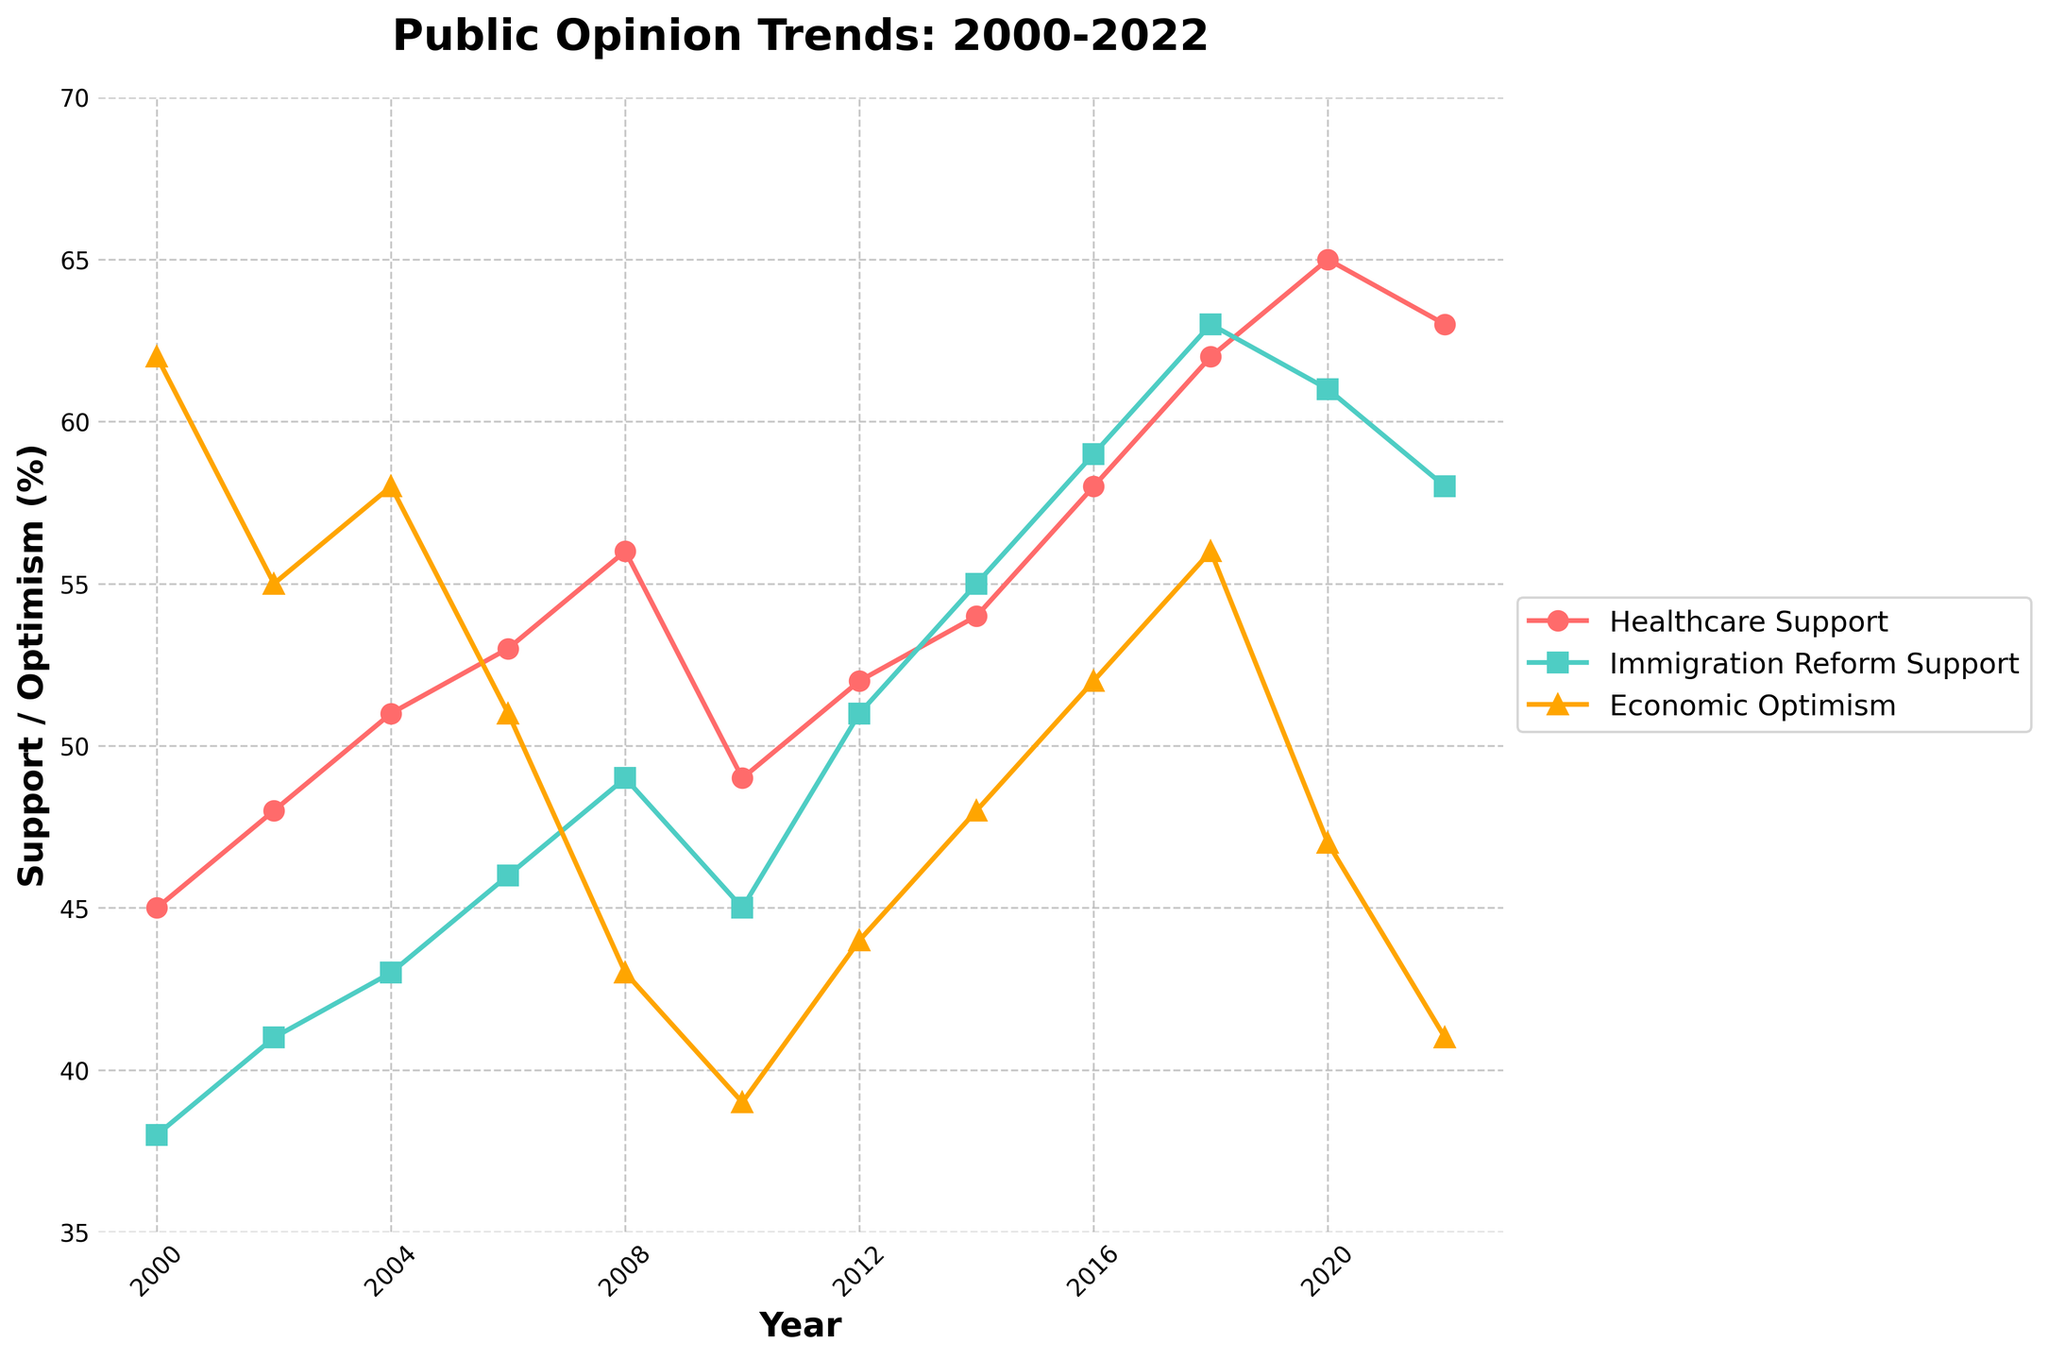What year had the highest support for healthcare? To determine the year with the highest support for healthcare, look at the points on the red line and compare their values. The highest point on the red line is in 2020 at 65%.
Answer: 2020 Which policy issue saw the most significant improvement in public support between 2000 and 2020? To find this, calculate the difference for each policy issue between 2000 and 2020. Healthcare: 65 - 45 = 20, Immigration: 61 - 38 = 23, Economy: 47 - 62 = -15. Immigration saw the most significant improvement.
Answer: Immigration In which year was public support for economic optimism at its lowest? Look at the yellow triangles along the timeline and identify the year with the lowest point. The lowest point is in 2010 at 39%.
Answer: 2010 Between 2014 and 2016, which policy issue had the highest increase in support? Calculate the differences for each policy issue between 2014 and 2016. Healthcare: 58 - 54 = 4, Immigration: 59 - 55 = 4, Economy: 52 - 48 = 4. All three had an equal increase in support of 4%.
Answer: All three What's the average support for Healthcare from 2010 to 2020? Calculate the average for Healthcare support over these years. Sum the values (49 + 52 + 54 + 58 + 62 + 65 + 63) = 403, then divide by the number of years (7). 403 / 7 = 57.57.
Answer: 57.57 In which year did support for immigration reform surpass that of economic optimism after 2010? Look for the first year after 2010 where the green line (immigration reform) is higher than the yellow line (economic optimism). In 2012, immigration is at 51%, while economic optimism is at 44%.
Answer: 2012 How much did immigration reform support increase between 2006 and 2014? Calculate the difference between the values in these years: 55 - 46 = 9. Support for immigration reform increased by 9%.
Answer: 9 Which year had the closest public support levels between healthcare and immigration reform? Find the year with the smallest difference between the values for healthcare (red line) and immigration reform (green line). In 2022, healthcare support is at 63% while immigration reform is at 58%. Difference is 5%.
Answer: 2022 From the data given, which policy issue shows the most fluctuation over the two decades? Evaluate the lines and look at their variability. The economic optimism line (yellow triangles) shows the most fluctuation with peaks and troughs.
Answer: Economic Optimism What's the trend of economic optimism between 2010 and 2022? Observe the yellow line from 2010 and follow through to 2022. It rises from 2010 to 2018 and then drops again by 2022.
Answer: Rise then fall 